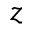<formula> <loc_0><loc_0><loc_500><loc_500>z</formula> 